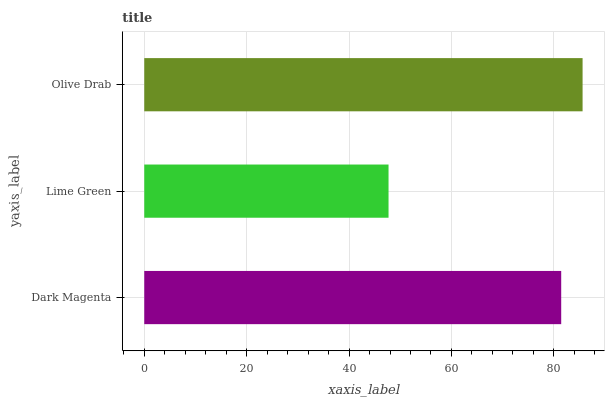Is Lime Green the minimum?
Answer yes or no. Yes. Is Olive Drab the maximum?
Answer yes or no. Yes. Is Olive Drab the minimum?
Answer yes or no. No. Is Lime Green the maximum?
Answer yes or no. No. Is Olive Drab greater than Lime Green?
Answer yes or no. Yes. Is Lime Green less than Olive Drab?
Answer yes or no. Yes. Is Lime Green greater than Olive Drab?
Answer yes or no. No. Is Olive Drab less than Lime Green?
Answer yes or no. No. Is Dark Magenta the high median?
Answer yes or no. Yes. Is Dark Magenta the low median?
Answer yes or no. Yes. Is Lime Green the high median?
Answer yes or no. No. Is Olive Drab the low median?
Answer yes or no. No. 